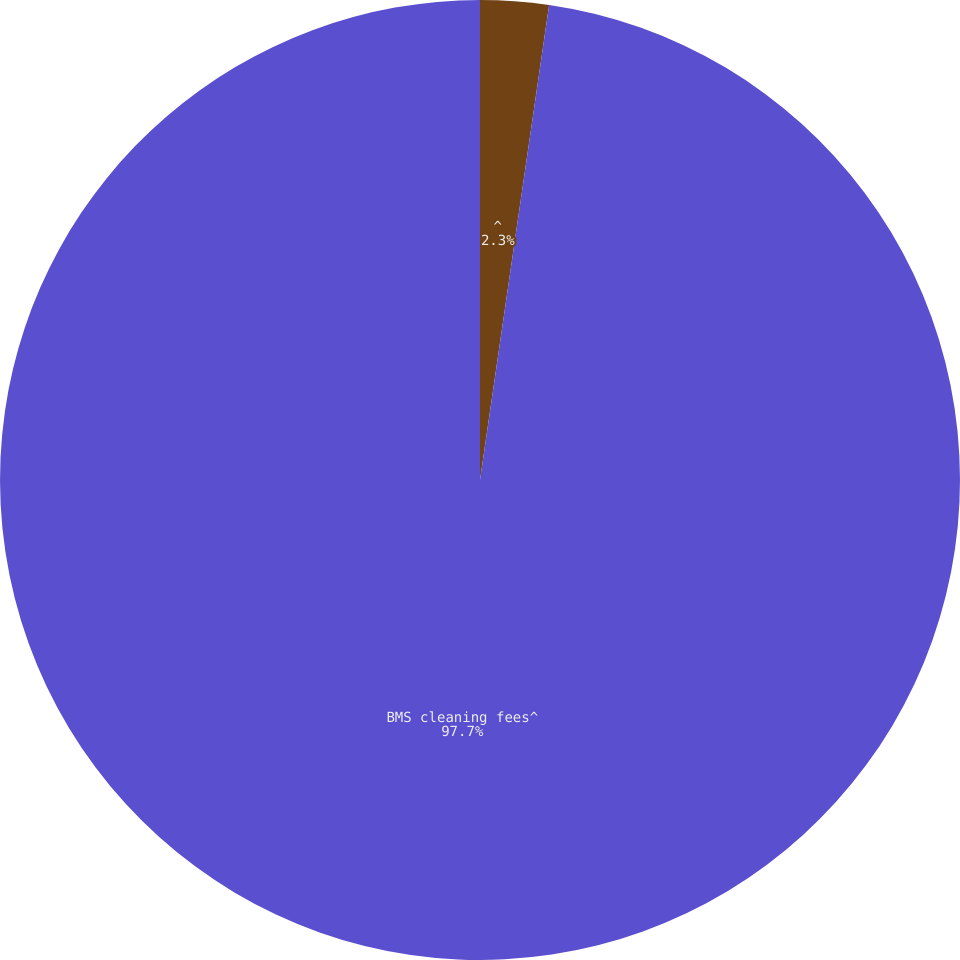Convert chart to OTSL. <chart><loc_0><loc_0><loc_500><loc_500><pie_chart><fcel>^<fcel>BMS cleaning fees^<nl><fcel>2.3%<fcel>97.7%<nl></chart> 